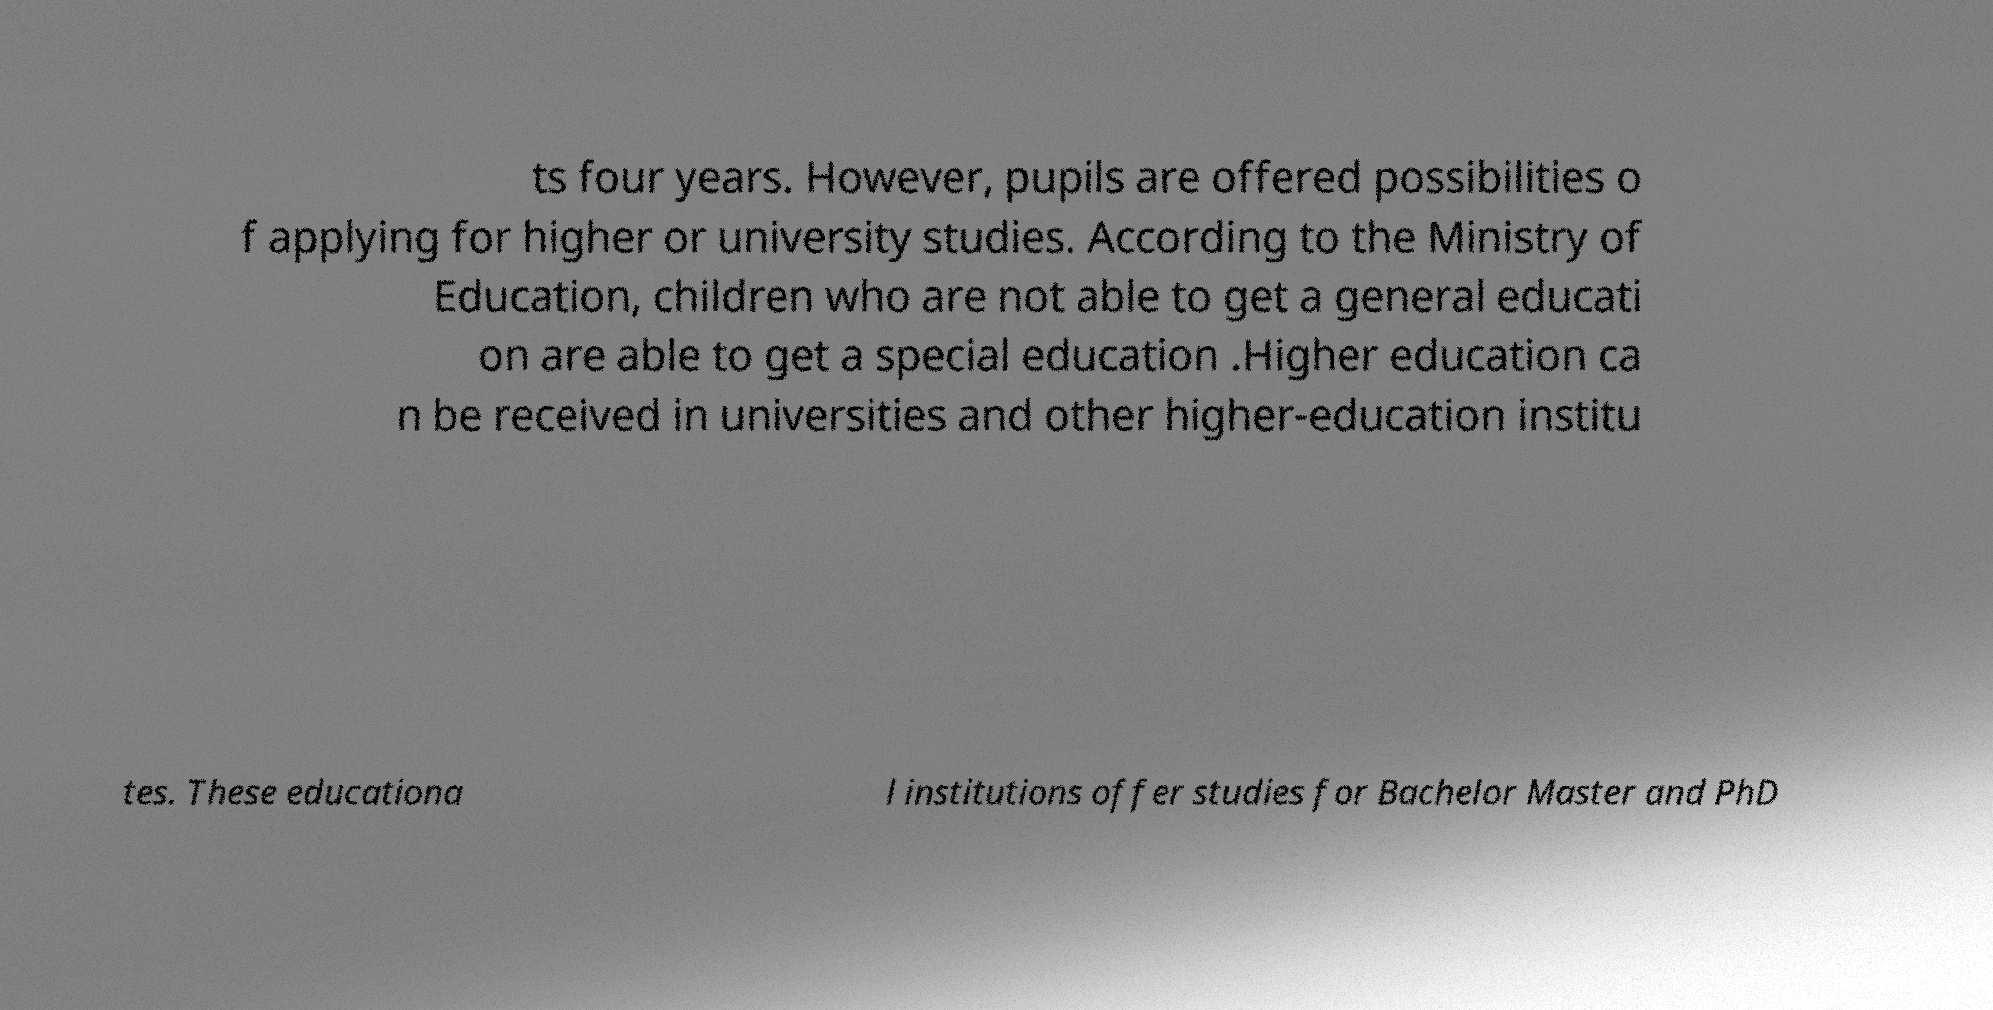Could you extract and type out the text from this image? ts four years. However, pupils are offered possibilities o f applying for higher or university studies. According to the Ministry of Education, children who are not able to get a general educati on are able to get a special education .Higher education ca n be received in universities and other higher-education institu tes. These educationa l institutions offer studies for Bachelor Master and PhD 